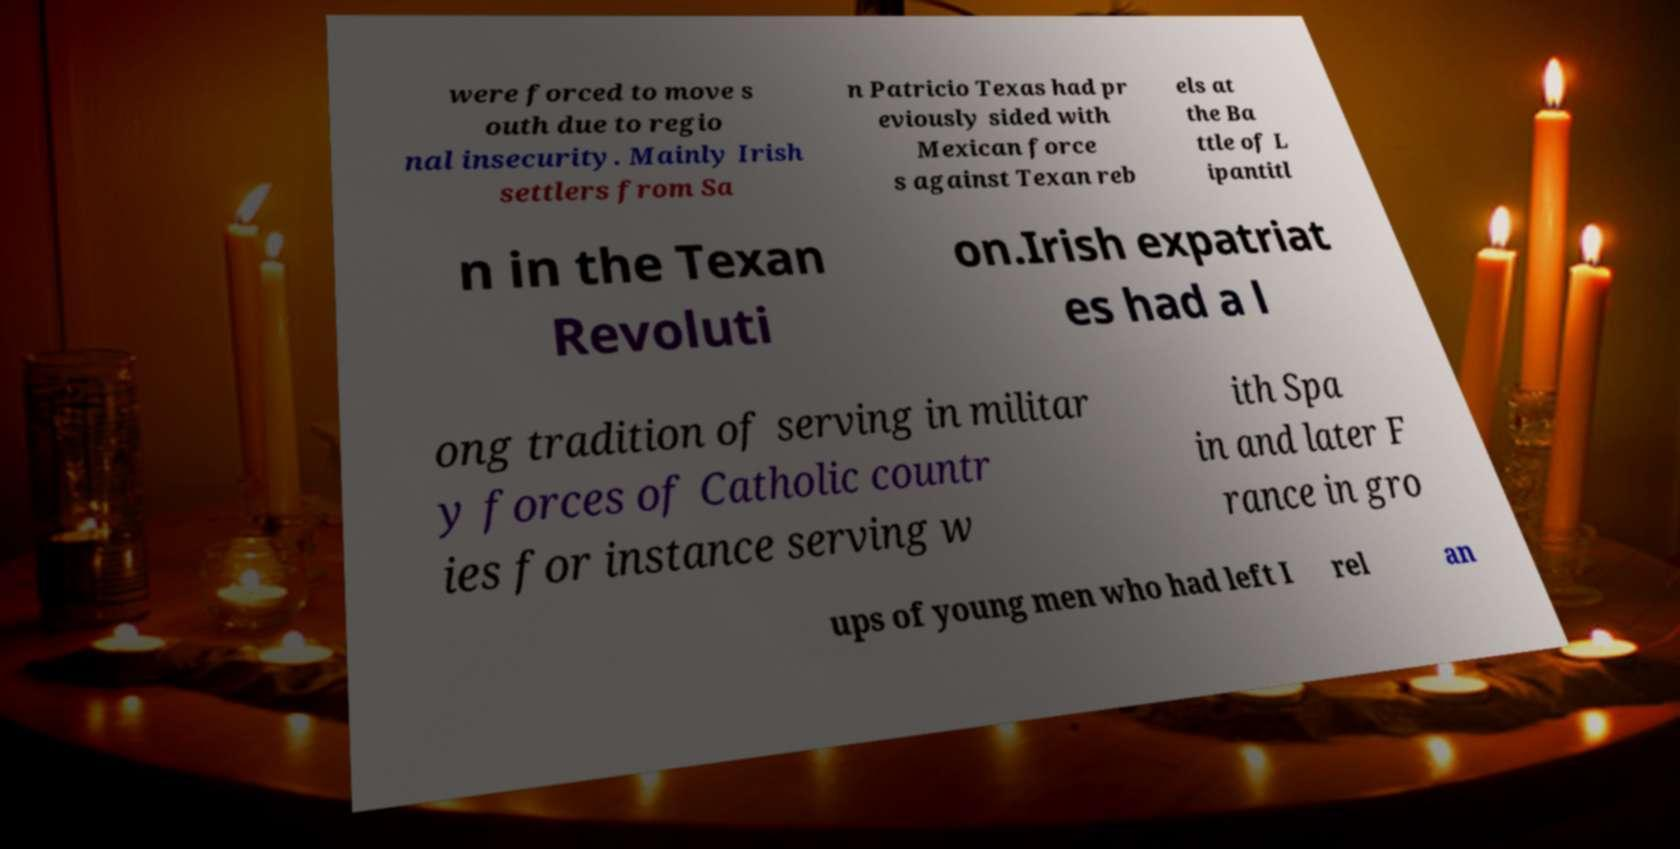Could you extract and type out the text from this image? were forced to move s outh due to regio nal insecurity. Mainly Irish settlers from Sa n Patricio Texas had pr eviously sided with Mexican force s against Texan reb els at the Ba ttle of L ipantitl n in the Texan Revoluti on.Irish expatriat es had a l ong tradition of serving in militar y forces of Catholic countr ies for instance serving w ith Spa in and later F rance in gro ups of young men who had left I rel an 